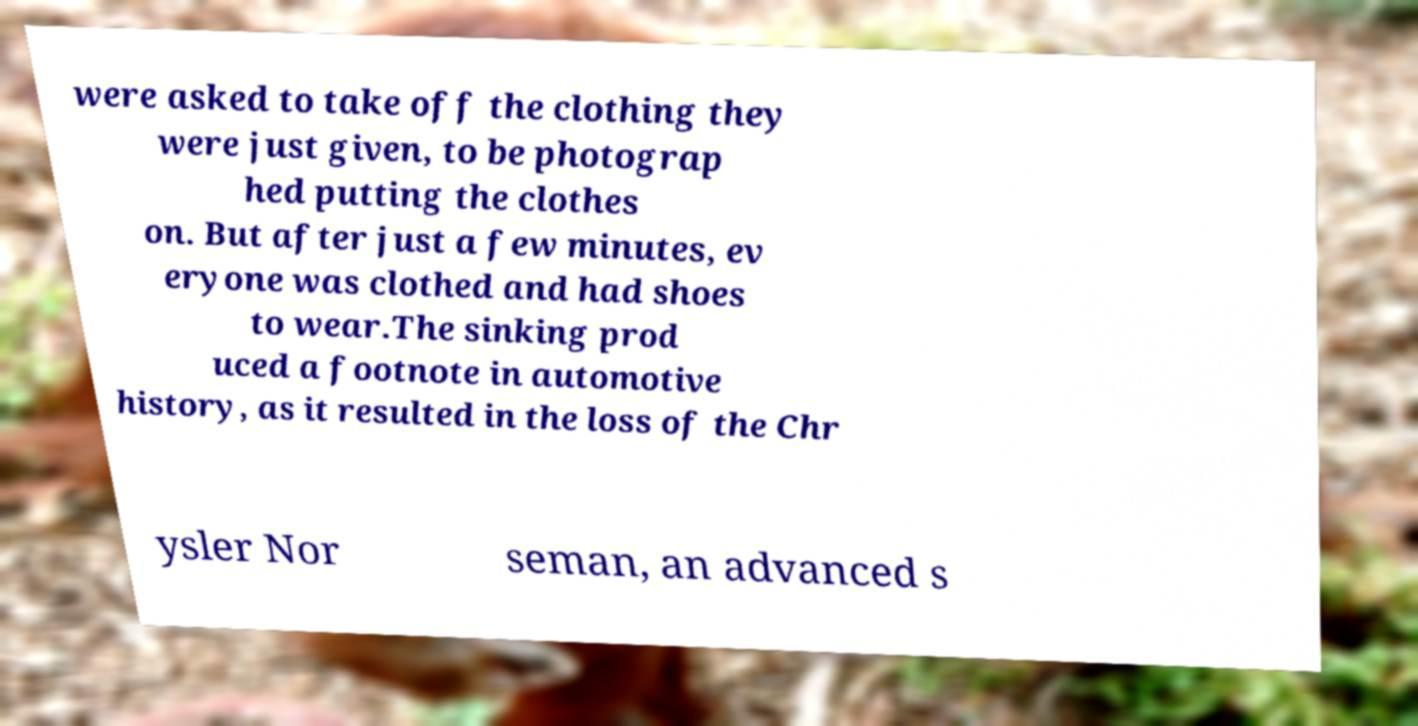For documentation purposes, I need the text within this image transcribed. Could you provide that? were asked to take off the clothing they were just given, to be photograp hed putting the clothes on. But after just a few minutes, ev eryone was clothed and had shoes to wear.The sinking prod uced a footnote in automotive history, as it resulted in the loss of the Chr ysler Nor seman, an advanced s 